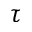<formula> <loc_0><loc_0><loc_500><loc_500>\tau</formula> 